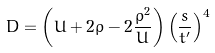Convert formula to latex. <formula><loc_0><loc_0><loc_500><loc_500>D = \left ( U + 2 \rho - 2 \frac { \rho ^ { 2 } } { U } \right ) \left ( \frac { s } { t ^ { \prime } } \right ) ^ { 4 }</formula> 